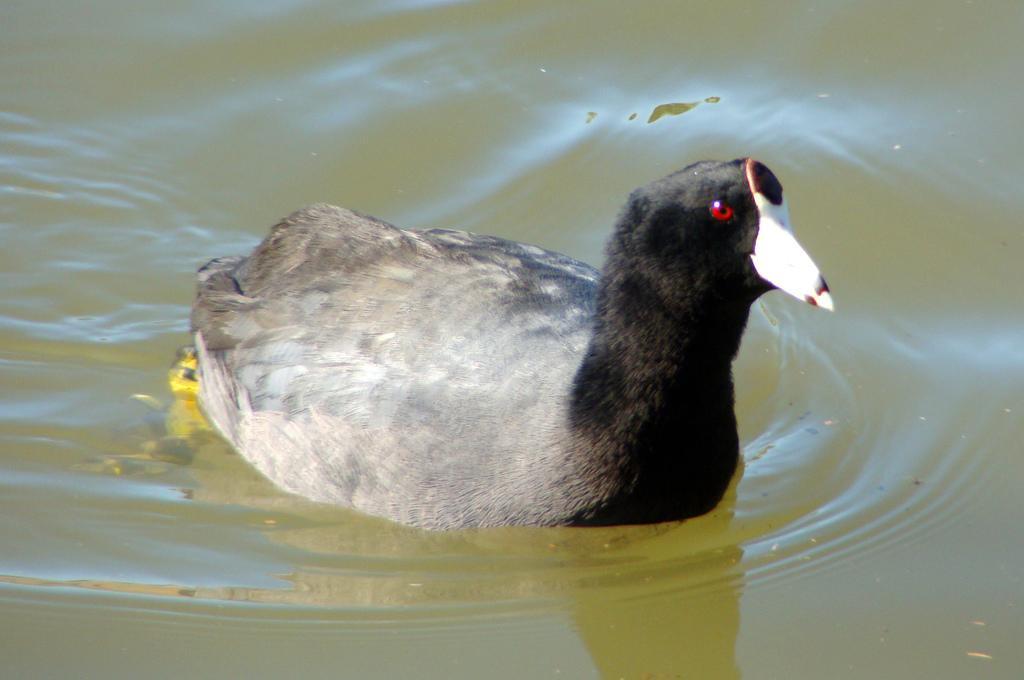How would you summarize this image in a sentence or two? In this picture we can observe a bird swimming in the water. This bird is in black and white color. In the background we can observe some water. 